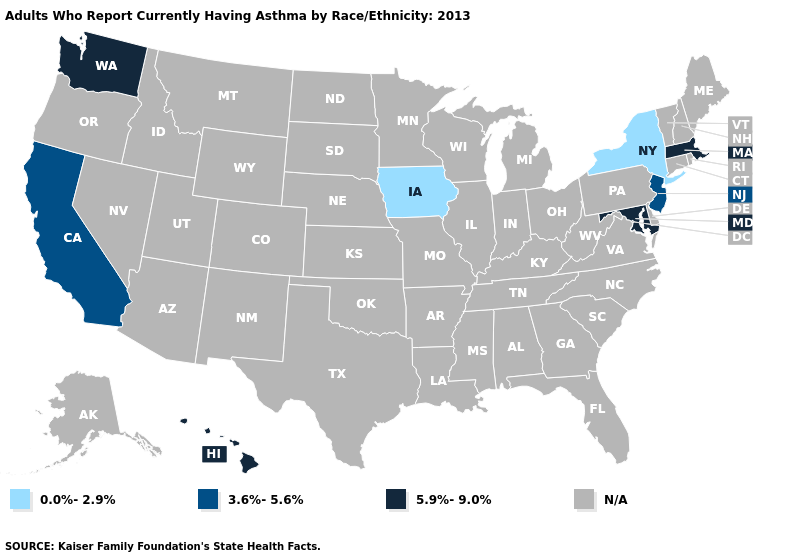Does New Jersey have the highest value in the Northeast?
Write a very short answer. No. Which states have the lowest value in the USA?
Quick response, please. Iowa, New York. What is the value of Delaware?
Short answer required. N/A. What is the value of Montana?
Answer briefly. N/A. Name the states that have a value in the range N/A?
Write a very short answer. Alabama, Alaska, Arizona, Arkansas, Colorado, Connecticut, Delaware, Florida, Georgia, Idaho, Illinois, Indiana, Kansas, Kentucky, Louisiana, Maine, Michigan, Minnesota, Mississippi, Missouri, Montana, Nebraska, Nevada, New Hampshire, New Mexico, North Carolina, North Dakota, Ohio, Oklahoma, Oregon, Pennsylvania, Rhode Island, South Carolina, South Dakota, Tennessee, Texas, Utah, Vermont, Virginia, West Virginia, Wisconsin, Wyoming. Name the states that have a value in the range 5.9%-9.0%?
Write a very short answer. Hawaii, Maryland, Massachusetts, Washington. What is the value of Louisiana?
Write a very short answer. N/A. What is the value of Idaho?
Concise answer only. N/A. What is the lowest value in the South?
Quick response, please. 5.9%-9.0%. Is the legend a continuous bar?
Give a very brief answer. No. Which states have the highest value in the USA?
Be succinct. Hawaii, Maryland, Massachusetts, Washington. 